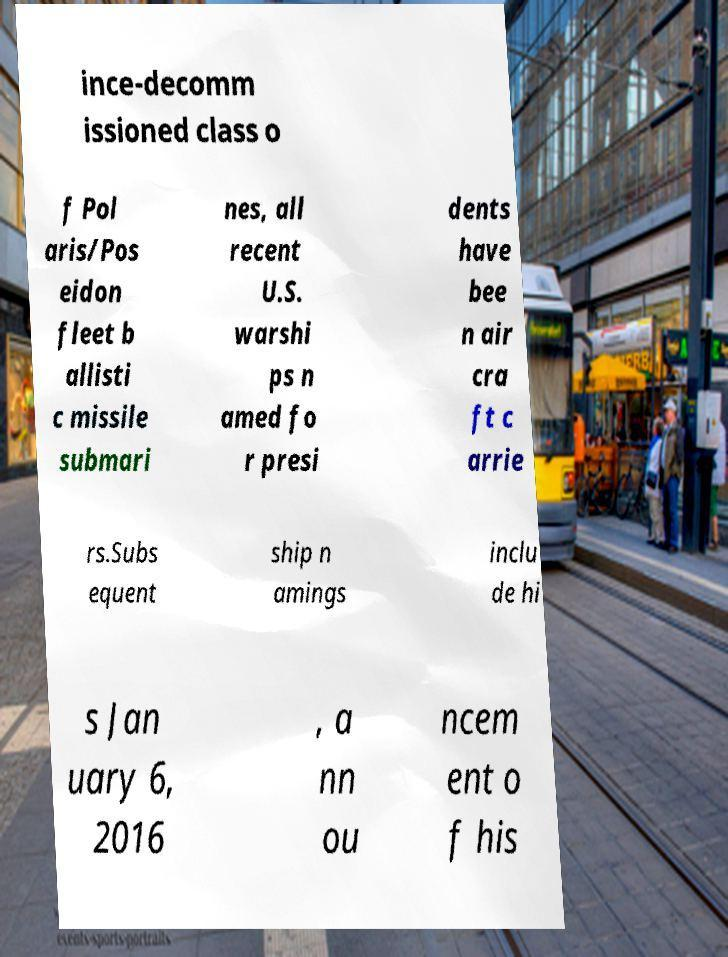For documentation purposes, I need the text within this image transcribed. Could you provide that? ince-decomm issioned class o f Pol aris/Pos eidon fleet b allisti c missile submari nes, all recent U.S. warshi ps n amed fo r presi dents have bee n air cra ft c arrie rs.Subs equent ship n amings inclu de hi s Jan uary 6, 2016 , a nn ou ncem ent o f his 